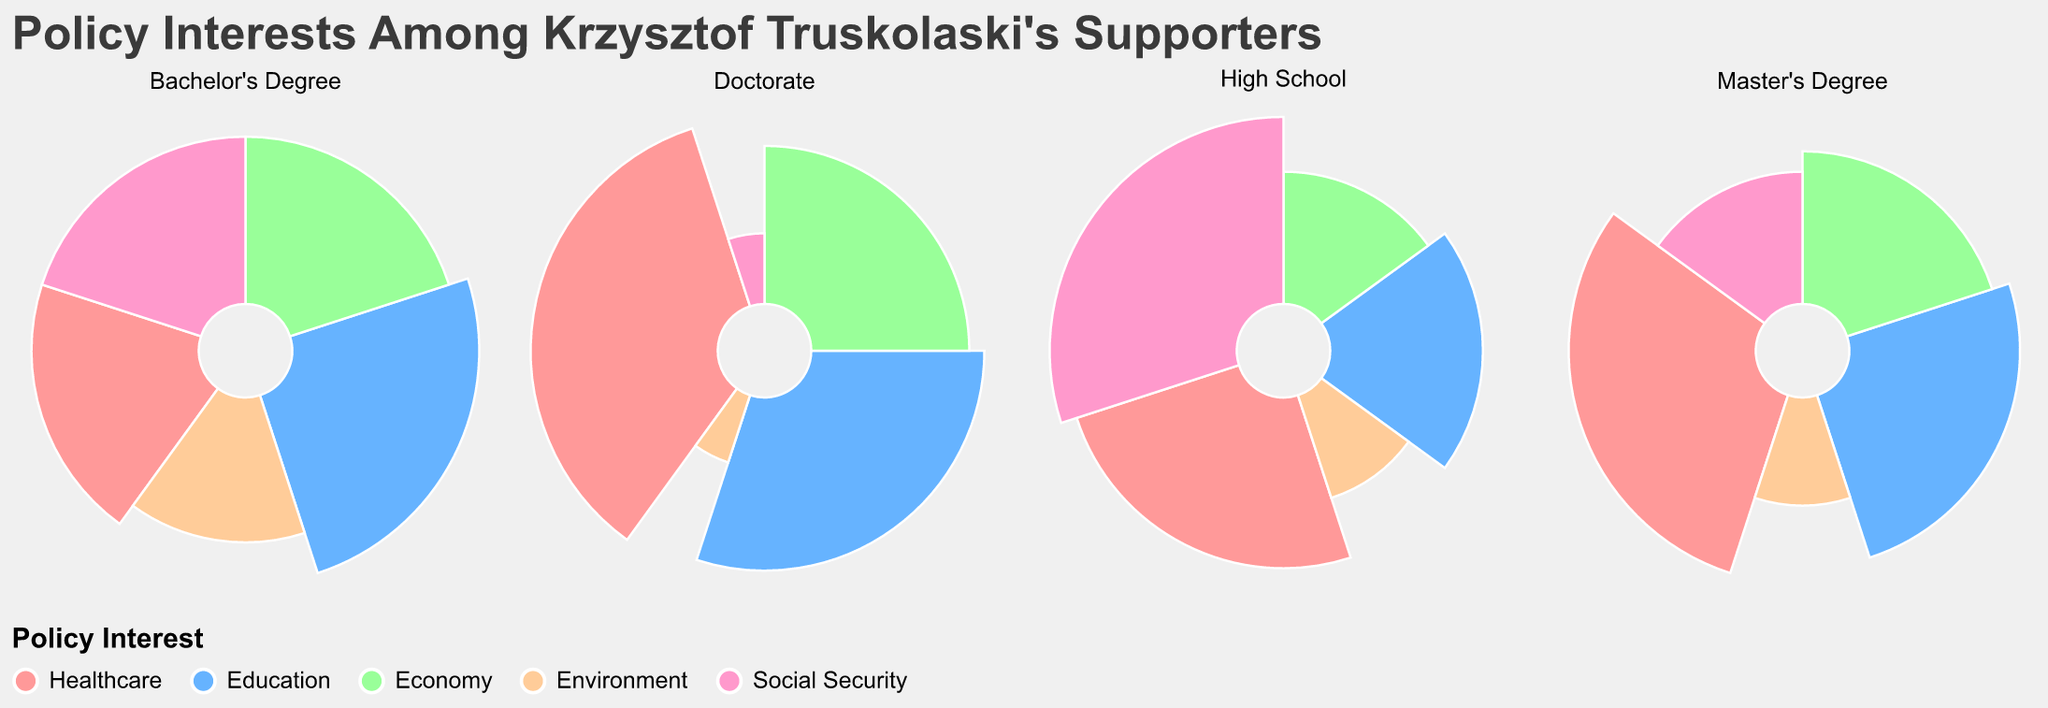What is the title of the chart? The title of the chart is given at the top and provides context to the data visualization.
Answer: Policy Interests Among Krzysztof Truskolaski’s Supporters Which policy interest has the highest support percentage among supporters with a High School education level? By looking at the sector with the largest visual representation in the subplot for High School, we can see which policy interest has the highest support percentage.
Answer: Social Security Which education level shows the most support for Healthcare? By comparing the size of the Healthcare sector across subplots for different education levels, the subplot with the largest Healthcare sector gives the answer.
Answer: Doctorate How does the support for Environment differ between supporters with a Bachelor's Degree and those with a Doctorate? Compare the sizes of the Environment sectors in the entries for Bachelor's Degree and Doctorate; these represent the percentage support for Environment in each educational level.
Answer: 15% (Bachelor's Degree) vs. 5% (Doctorate) What is the support percentage for Education among Master's Degree holders, and how does it compare to High School graduates? Observe the Education sector in the Master's Degree subplot and High School subplot, and note the support percentages. This comparison shows the difference.
Answer: 25% (Master's Degree) vs. 20% (High School) Which education level has the least interest in Economy? By identifying the subplot with the smallest sector for Economy, we can determine which education level shows the least support for this policy.
Answer: High School Is there an education level where Social Security is not the top policy interest? Check each subplot to see if any education level has a different policy as the largest sector.
Answer: Yes, Doctorate What is the sum of support percentages for Healthcare and Education among Doctorate holders? Add the support percentages for Healthcare and Education from the Doctorate subplot.
Answer: 65% How does the distribution of policy interests differ between High School and Doctorate education levels? Compare the size of each sector (Healthcare, Education, Economy, Environment, Social Security) in the subplots for High School and Doctorate to describe how the proportions vary.
Answer: High School has higher support for Social Security, less for Healthcare and Education compared to Doctorate, where Healthcare is most prominent Which policy interest shows the least amount of support among Master's Degree holders, and what percentage does it have? Identify the smallest sector in the Master's Degree subplot; the size of this sector represents the percentage of support.
Answer: Environment, 10% 